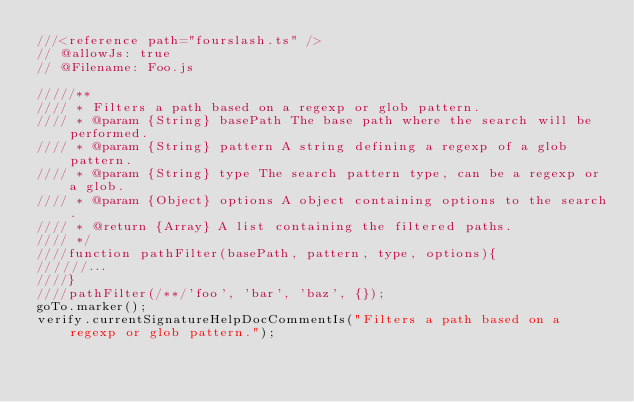<code> <loc_0><loc_0><loc_500><loc_500><_TypeScript_>///<reference path="fourslash.ts" />
// @allowJs: true
// @Filename: Foo.js

/////**
//// * Filters a path based on a regexp or glob pattern.
//// * @param {String} basePath The base path where the search will be performed.
//// * @param {String} pattern A string defining a regexp of a glob pattern.
//// * @param {String} type The search pattern type, can be a regexp or a glob.
//// * @param {Object} options A object containing options to the search.
//// * @return {Array} A list containing the filtered paths.
//// */
////function pathFilter(basePath, pattern, type, options){
//////...
////}
////pathFilter(/**/'foo', 'bar', 'baz', {});
goTo.marker();
verify.currentSignatureHelpDocCommentIs("Filters a path based on a regexp or glob pattern.");
</code> 